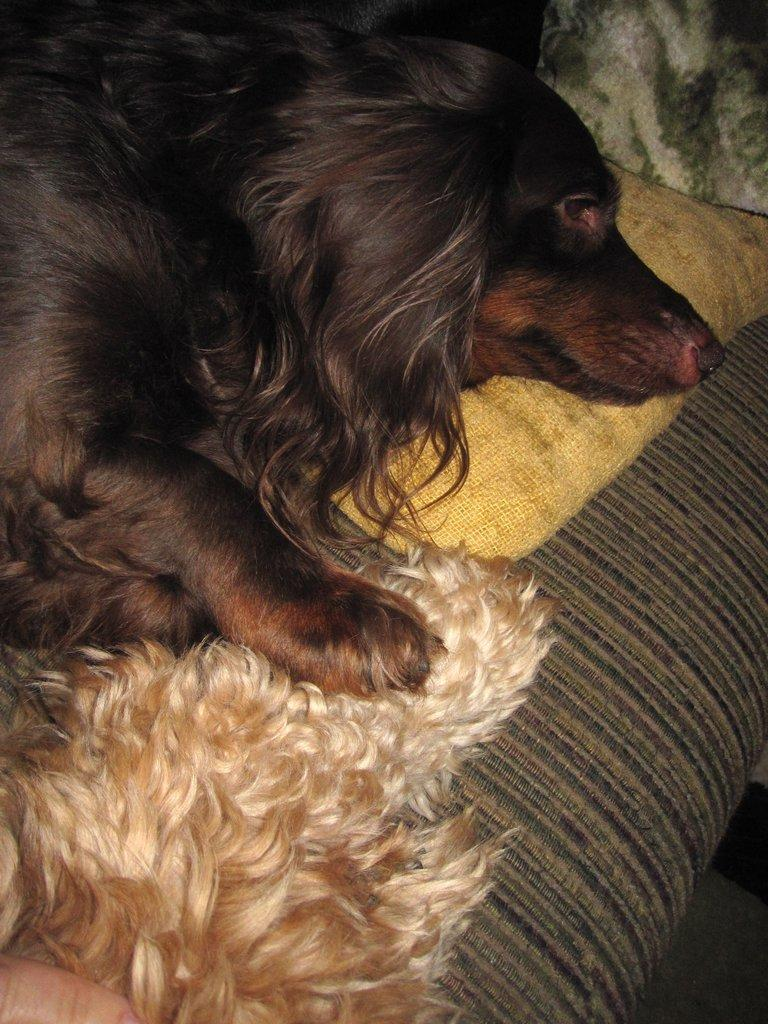What animal is on the couch in the image? There is a dog on the couch in the image. Can you see any part of a person in the image? Yes, a person's finger is visible in the image. What type of furniture is the dog sitting on? The dog is sitting on a couch. What object is present on the couch? There is a cushion in the image. What time of day is depicted in the image? The time of day is not visible in the image, as there are no clocks or other time-related objects present. 